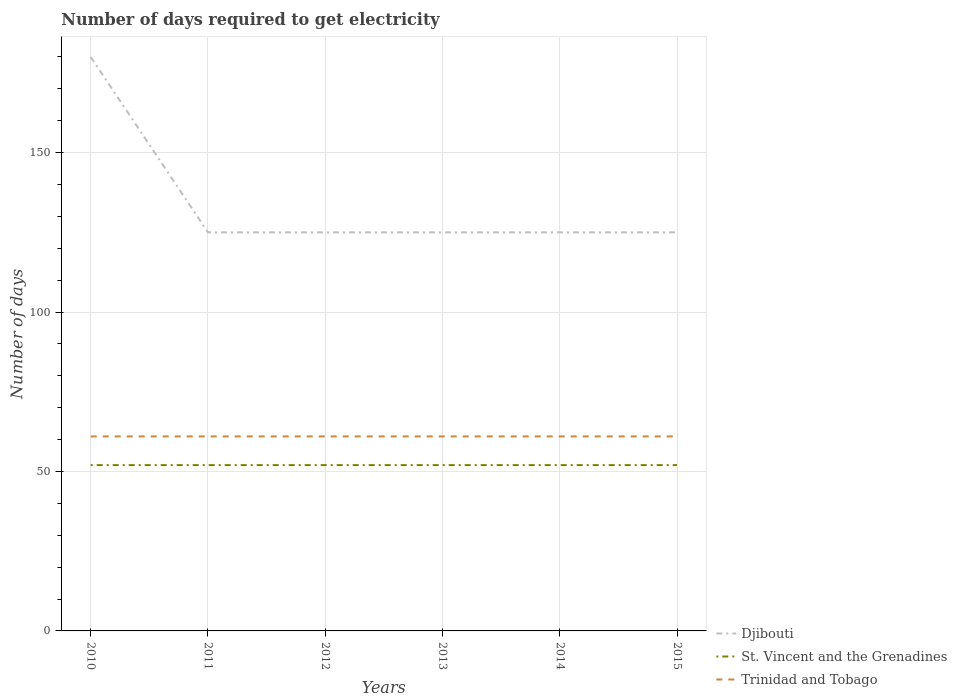How many different coloured lines are there?
Your answer should be very brief. 3. Is the number of lines equal to the number of legend labels?
Offer a very short reply. Yes. Across all years, what is the maximum number of days required to get electricity in in Trinidad and Tobago?
Keep it short and to the point. 61. What is the difference between the highest and the second highest number of days required to get electricity in in St. Vincent and the Grenadines?
Ensure brevity in your answer.  0. What is the difference between the highest and the lowest number of days required to get electricity in in Djibouti?
Your answer should be very brief. 1. How many years are there in the graph?
Provide a succinct answer. 6. What is the difference between two consecutive major ticks on the Y-axis?
Give a very brief answer. 50. Are the values on the major ticks of Y-axis written in scientific E-notation?
Your answer should be compact. No. Does the graph contain grids?
Provide a short and direct response. Yes. How many legend labels are there?
Your response must be concise. 3. What is the title of the graph?
Offer a terse response. Number of days required to get electricity. Does "Latin America(developing only)" appear as one of the legend labels in the graph?
Offer a very short reply. No. What is the label or title of the Y-axis?
Offer a very short reply. Number of days. What is the Number of days in Djibouti in 2010?
Provide a short and direct response. 180. What is the Number of days of St. Vincent and the Grenadines in 2010?
Offer a very short reply. 52. What is the Number of days in Djibouti in 2011?
Keep it short and to the point. 125. What is the Number of days of St. Vincent and the Grenadines in 2011?
Keep it short and to the point. 52. What is the Number of days in Trinidad and Tobago in 2011?
Your answer should be compact. 61. What is the Number of days of Djibouti in 2012?
Ensure brevity in your answer.  125. What is the Number of days of St. Vincent and the Grenadines in 2012?
Your answer should be compact. 52. What is the Number of days of Trinidad and Tobago in 2012?
Provide a succinct answer. 61. What is the Number of days of Djibouti in 2013?
Your response must be concise. 125. What is the Number of days in Trinidad and Tobago in 2013?
Give a very brief answer. 61. What is the Number of days in Djibouti in 2014?
Keep it short and to the point. 125. What is the Number of days of Djibouti in 2015?
Offer a very short reply. 125. What is the Number of days in Trinidad and Tobago in 2015?
Provide a succinct answer. 61. Across all years, what is the maximum Number of days in Djibouti?
Your answer should be compact. 180. Across all years, what is the maximum Number of days of St. Vincent and the Grenadines?
Your response must be concise. 52. Across all years, what is the minimum Number of days in Djibouti?
Your answer should be compact. 125. Across all years, what is the minimum Number of days in Trinidad and Tobago?
Offer a terse response. 61. What is the total Number of days of Djibouti in the graph?
Your response must be concise. 805. What is the total Number of days of St. Vincent and the Grenadines in the graph?
Offer a terse response. 312. What is the total Number of days of Trinidad and Tobago in the graph?
Ensure brevity in your answer.  366. What is the difference between the Number of days of St. Vincent and the Grenadines in 2010 and that in 2011?
Keep it short and to the point. 0. What is the difference between the Number of days of St. Vincent and the Grenadines in 2010 and that in 2012?
Your answer should be compact. 0. What is the difference between the Number of days in Trinidad and Tobago in 2010 and that in 2012?
Keep it short and to the point. 0. What is the difference between the Number of days of Djibouti in 2010 and that in 2013?
Make the answer very short. 55. What is the difference between the Number of days in Trinidad and Tobago in 2010 and that in 2013?
Give a very brief answer. 0. What is the difference between the Number of days of Djibouti in 2010 and that in 2014?
Provide a short and direct response. 55. What is the difference between the Number of days of St. Vincent and the Grenadines in 2010 and that in 2014?
Give a very brief answer. 0. What is the difference between the Number of days in Djibouti in 2010 and that in 2015?
Offer a terse response. 55. What is the difference between the Number of days in St. Vincent and the Grenadines in 2010 and that in 2015?
Keep it short and to the point. 0. What is the difference between the Number of days of Djibouti in 2011 and that in 2012?
Make the answer very short. 0. What is the difference between the Number of days of St. Vincent and the Grenadines in 2011 and that in 2012?
Your answer should be very brief. 0. What is the difference between the Number of days of Trinidad and Tobago in 2011 and that in 2012?
Offer a very short reply. 0. What is the difference between the Number of days in Djibouti in 2011 and that in 2013?
Make the answer very short. 0. What is the difference between the Number of days in Trinidad and Tobago in 2011 and that in 2013?
Ensure brevity in your answer.  0. What is the difference between the Number of days in Djibouti in 2011 and that in 2014?
Offer a terse response. 0. What is the difference between the Number of days of Trinidad and Tobago in 2011 and that in 2014?
Offer a terse response. 0. What is the difference between the Number of days in Djibouti in 2011 and that in 2015?
Provide a short and direct response. 0. What is the difference between the Number of days in Trinidad and Tobago in 2011 and that in 2015?
Give a very brief answer. 0. What is the difference between the Number of days in Djibouti in 2012 and that in 2013?
Make the answer very short. 0. What is the difference between the Number of days of St. Vincent and the Grenadines in 2012 and that in 2013?
Provide a succinct answer. 0. What is the difference between the Number of days of Trinidad and Tobago in 2012 and that in 2013?
Your answer should be compact. 0. What is the difference between the Number of days of Djibouti in 2012 and that in 2014?
Offer a terse response. 0. What is the difference between the Number of days of St. Vincent and the Grenadines in 2012 and that in 2014?
Provide a short and direct response. 0. What is the difference between the Number of days in Trinidad and Tobago in 2012 and that in 2014?
Provide a short and direct response. 0. What is the difference between the Number of days in Trinidad and Tobago in 2012 and that in 2015?
Provide a short and direct response. 0. What is the difference between the Number of days in Djibouti in 2013 and that in 2014?
Keep it short and to the point. 0. What is the difference between the Number of days of St. Vincent and the Grenadines in 2013 and that in 2014?
Offer a very short reply. 0. What is the difference between the Number of days of St. Vincent and the Grenadines in 2013 and that in 2015?
Offer a terse response. 0. What is the difference between the Number of days of Djibouti in 2014 and that in 2015?
Ensure brevity in your answer.  0. What is the difference between the Number of days in Trinidad and Tobago in 2014 and that in 2015?
Give a very brief answer. 0. What is the difference between the Number of days in Djibouti in 2010 and the Number of days in St. Vincent and the Grenadines in 2011?
Offer a terse response. 128. What is the difference between the Number of days of Djibouti in 2010 and the Number of days of Trinidad and Tobago in 2011?
Give a very brief answer. 119. What is the difference between the Number of days in St. Vincent and the Grenadines in 2010 and the Number of days in Trinidad and Tobago in 2011?
Offer a very short reply. -9. What is the difference between the Number of days of Djibouti in 2010 and the Number of days of St. Vincent and the Grenadines in 2012?
Provide a succinct answer. 128. What is the difference between the Number of days of Djibouti in 2010 and the Number of days of Trinidad and Tobago in 2012?
Your answer should be compact. 119. What is the difference between the Number of days in St. Vincent and the Grenadines in 2010 and the Number of days in Trinidad and Tobago in 2012?
Your answer should be very brief. -9. What is the difference between the Number of days of Djibouti in 2010 and the Number of days of St. Vincent and the Grenadines in 2013?
Make the answer very short. 128. What is the difference between the Number of days of Djibouti in 2010 and the Number of days of Trinidad and Tobago in 2013?
Your answer should be compact. 119. What is the difference between the Number of days of Djibouti in 2010 and the Number of days of St. Vincent and the Grenadines in 2014?
Your answer should be very brief. 128. What is the difference between the Number of days of Djibouti in 2010 and the Number of days of Trinidad and Tobago in 2014?
Your answer should be compact. 119. What is the difference between the Number of days in Djibouti in 2010 and the Number of days in St. Vincent and the Grenadines in 2015?
Your answer should be very brief. 128. What is the difference between the Number of days in Djibouti in 2010 and the Number of days in Trinidad and Tobago in 2015?
Ensure brevity in your answer.  119. What is the difference between the Number of days in Djibouti in 2011 and the Number of days in St. Vincent and the Grenadines in 2012?
Ensure brevity in your answer.  73. What is the difference between the Number of days in Djibouti in 2011 and the Number of days in St. Vincent and the Grenadines in 2013?
Your answer should be compact. 73. What is the difference between the Number of days in Djibouti in 2011 and the Number of days in Trinidad and Tobago in 2013?
Offer a terse response. 64. What is the difference between the Number of days of Djibouti in 2011 and the Number of days of St. Vincent and the Grenadines in 2015?
Keep it short and to the point. 73. What is the difference between the Number of days of Djibouti in 2011 and the Number of days of Trinidad and Tobago in 2015?
Ensure brevity in your answer.  64. What is the difference between the Number of days of Djibouti in 2012 and the Number of days of St. Vincent and the Grenadines in 2013?
Your answer should be compact. 73. What is the difference between the Number of days of St. Vincent and the Grenadines in 2012 and the Number of days of Trinidad and Tobago in 2013?
Your answer should be very brief. -9. What is the difference between the Number of days of Djibouti in 2012 and the Number of days of St. Vincent and the Grenadines in 2014?
Provide a short and direct response. 73. What is the difference between the Number of days of Djibouti in 2012 and the Number of days of Trinidad and Tobago in 2014?
Give a very brief answer. 64. What is the difference between the Number of days of Djibouti in 2013 and the Number of days of Trinidad and Tobago in 2015?
Offer a terse response. 64. What is the difference between the Number of days of Djibouti in 2014 and the Number of days of St. Vincent and the Grenadines in 2015?
Keep it short and to the point. 73. What is the difference between the Number of days in Djibouti in 2014 and the Number of days in Trinidad and Tobago in 2015?
Give a very brief answer. 64. What is the difference between the Number of days of St. Vincent and the Grenadines in 2014 and the Number of days of Trinidad and Tobago in 2015?
Keep it short and to the point. -9. What is the average Number of days in Djibouti per year?
Your answer should be very brief. 134.17. What is the average Number of days of St. Vincent and the Grenadines per year?
Offer a very short reply. 52. What is the average Number of days in Trinidad and Tobago per year?
Your answer should be compact. 61. In the year 2010, what is the difference between the Number of days of Djibouti and Number of days of St. Vincent and the Grenadines?
Offer a terse response. 128. In the year 2010, what is the difference between the Number of days of Djibouti and Number of days of Trinidad and Tobago?
Make the answer very short. 119. In the year 2010, what is the difference between the Number of days of St. Vincent and the Grenadines and Number of days of Trinidad and Tobago?
Provide a short and direct response. -9. In the year 2011, what is the difference between the Number of days in Djibouti and Number of days in St. Vincent and the Grenadines?
Give a very brief answer. 73. In the year 2011, what is the difference between the Number of days of St. Vincent and the Grenadines and Number of days of Trinidad and Tobago?
Offer a very short reply. -9. In the year 2012, what is the difference between the Number of days in Djibouti and Number of days in Trinidad and Tobago?
Keep it short and to the point. 64. In the year 2013, what is the difference between the Number of days of Djibouti and Number of days of St. Vincent and the Grenadines?
Provide a short and direct response. 73. In the year 2013, what is the difference between the Number of days of St. Vincent and the Grenadines and Number of days of Trinidad and Tobago?
Your answer should be very brief. -9. In the year 2014, what is the difference between the Number of days in Djibouti and Number of days in Trinidad and Tobago?
Your response must be concise. 64. In the year 2014, what is the difference between the Number of days of St. Vincent and the Grenadines and Number of days of Trinidad and Tobago?
Ensure brevity in your answer.  -9. In the year 2015, what is the difference between the Number of days in Djibouti and Number of days in Trinidad and Tobago?
Your response must be concise. 64. In the year 2015, what is the difference between the Number of days in St. Vincent and the Grenadines and Number of days in Trinidad and Tobago?
Give a very brief answer. -9. What is the ratio of the Number of days of Djibouti in 2010 to that in 2011?
Make the answer very short. 1.44. What is the ratio of the Number of days of Trinidad and Tobago in 2010 to that in 2011?
Make the answer very short. 1. What is the ratio of the Number of days of Djibouti in 2010 to that in 2012?
Provide a short and direct response. 1.44. What is the ratio of the Number of days in Djibouti in 2010 to that in 2013?
Make the answer very short. 1.44. What is the ratio of the Number of days of Trinidad and Tobago in 2010 to that in 2013?
Give a very brief answer. 1. What is the ratio of the Number of days in Djibouti in 2010 to that in 2014?
Keep it short and to the point. 1.44. What is the ratio of the Number of days in St. Vincent and the Grenadines in 2010 to that in 2014?
Provide a short and direct response. 1. What is the ratio of the Number of days in Djibouti in 2010 to that in 2015?
Your response must be concise. 1.44. What is the ratio of the Number of days of St. Vincent and the Grenadines in 2010 to that in 2015?
Your answer should be compact. 1. What is the ratio of the Number of days of Djibouti in 2011 to that in 2014?
Provide a short and direct response. 1. What is the ratio of the Number of days of St. Vincent and the Grenadines in 2011 to that in 2014?
Provide a succinct answer. 1. What is the ratio of the Number of days of St. Vincent and the Grenadines in 2011 to that in 2015?
Your response must be concise. 1. What is the ratio of the Number of days of Djibouti in 2012 to that in 2013?
Provide a succinct answer. 1. What is the ratio of the Number of days in Trinidad and Tobago in 2012 to that in 2014?
Offer a terse response. 1. What is the ratio of the Number of days of St. Vincent and the Grenadines in 2012 to that in 2015?
Your response must be concise. 1. What is the ratio of the Number of days in Trinidad and Tobago in 2012 to that in 2015?
Provide a short and direct response. 1. What is the ratio of the Number of days in Trinidad and Tobago in 2013 to that in 2014?
Your response must be concise. 1. What is the ratio of the Number of days in Trinidad and Tobago in 2013 to that in 2015?
Provide a short and direct response. 1. What is the ratio of the Number of days of Djibouti in 2014 to that in 2015?
Offer a very short reply. 1. What is the ratio of the Number of days of St. Vincent and the Grenadines in 2014 to that in 2015?
Offer a terse response. 1. What is the ratio of the Number of days of Trinidad and Tobago in 2014 to that in 2015?
Give a very brief answer. 1. What is the difference between the highest and the second highest Number of days in Trinidad and Tobago?
Give a very brief answer. 0. What is the difference between the highest and the lowest Number of days in Djibouti?
Provide a short and direct response. 55. 